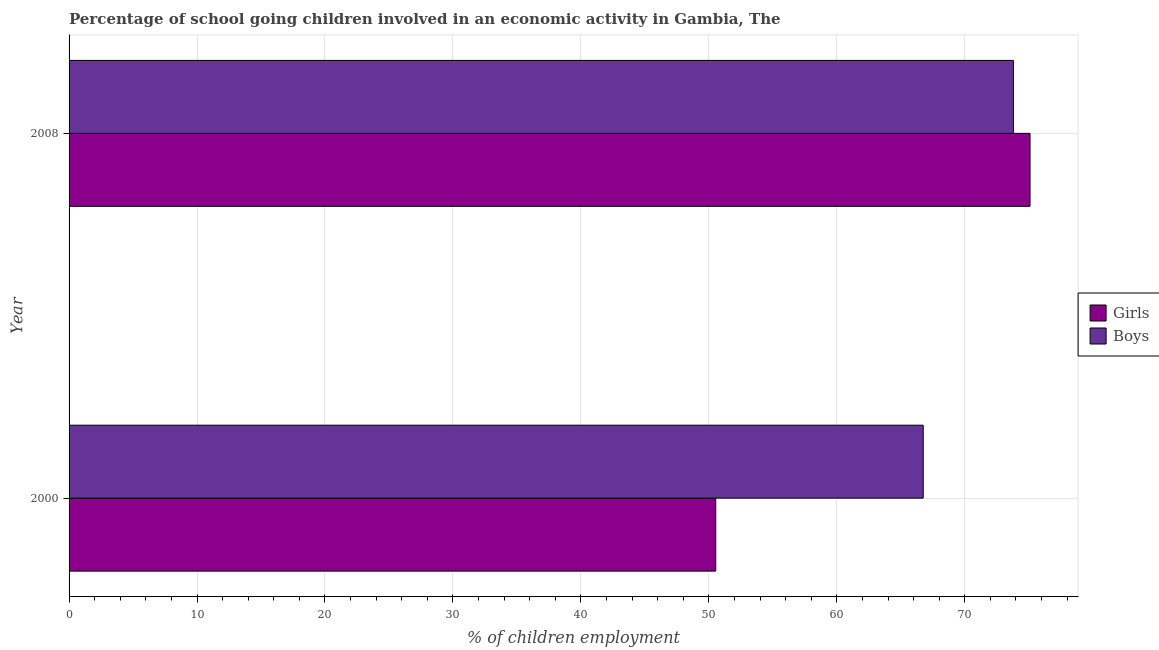How many different coloured bars are there?
Your answer should be very brief. 2. How many groups of bars are there?
Make the answer very short. 2. How many bars are there on the 2nd tick from the top?
Offer a terse response. 2. What is the label of the 2nd group of bars from the top?
Make the answer very short. 2000. What is the percentage of school going girls in 2000?
Your answer should be compact. 50.54. Across all years, what is the maximum percentage of school going girls?
Offer a very short reply. 75.1. Across all years, what is the minimum percentage of school going girls?
Your answer should be very brief. 50.54. In which year was the percentage of school going boys maximum?
Make the answer very short. 2008. In which year was the percentage of school going girls minimum?
Offer a terse response. 2000. What is the total percentage of school going boys in the graph?
Your answer should be very brief. 140.55. What is the difference between the percentage of school going girls in 2000 and that in 2008?
Make the answer very short. -24.56. What is the difference between the percentage of school going girls in 2000 and the percentage of school going boys in 2008?
Give a very brief answer. -23.26. What is the average percentage of school going boys per year?
Make the answer very short. 70.28. In how many years, is the percentage of school going boys greater than 72 %?
Make the answer very short. 1. What is the ratio of the percentage of school going boys in 2000 to that in 2008?
Your answer should be very brief. 0.9. Is the difference between the percentage of school going girls in 2000 and 2008 greater than the difference between the percentage of school going boys in 2000 and 2008?
Ensure brevity in your answer.  No. What does the 1st bar from the top in 2000 represents?
Keep it short and to the point. Boys. What does the 2nd bar from the bottom in 2000 represents?
Offer a very short reply. Boys. How many bars are there?
Your answer should be very brief. 4. Are all the bars in the graph horizontal?
Give a very brief answer. Yes. How many years are there in the graph?
Your response must be concise. 2. Does the graph contain grids?
Offer a very short reply. Yes. Where does the legend appear in the graph?
Offer a terse response. Center right. What is the title of the graph?
Your answer should be very brief. Percentage of school going children involved in an economic activity in Gambia, The. Does "From World Bank" appear as one of the legend labels in the graph?
Your answer should be compact. No. What is the label or title of the X-axis?
Your response must be concise. % of children employment. What is the label or title of the Y-axis?
Your answer should be very brief. Year. What is the % of children employment in Girls in 2000?
Offer a terse response. 50.54. What is the % of children employment of Boys in 2000?
Offer a very short reply. 66.75. What is the % of children employment in Girls in 2008?
Your response must be concise. 75.1. What is the % of children employment in Boys in 2008?
Give a very brief answer. 73.8. Across all years, what is the maximum % of children employment in Girls?
Offer a very short reply. 75.1. Across all years, what is the maximum % of children employment in Boys?
Your answer should be very brief. 73.8. Across all years, what is the minimum % of children employment in Girls?
Your response must be concise. 50.54. Across all years, what is the minimum % of children employment in Boys?
Offer a terse response. 66.75. What is the total % of children employment of Girls in the graph?
Give a very brief answer. 125.64. What is the total % of children employment of Boys in the graph?
Your answer should be very brief. 140.55. What is the difference between the % of children employment in Girls in 2000 and that in 2008?
Give a very brief answer. -24.56. What is the difference between the % of children employment of Boys in 2000 and that in 2008?
Give a very brief answer. -7.05. What is the difference between the % of children employment in Girls in 2000 and the % of children employment in Boys in 2008?
Provide a short and direct response. -23.26. What is the average % of children employment of Girls per year?
Provide a short and direct response. 62.82. What is the average % of children employment of Boys per year?
Keep it short and to the point. 70.28. In the year 2000, what is the difference between the % of children employment in Girls and % of children employment in Boys?
Provide a short and direct response. -16.21. In the year 2008, what is the difference between the % of children employment of Girls and % of children employment of Boys?
Offer a terse response. 1.3. What is the ratio of the % of children employment of Girls in 2000 to that in 2008?
Provide a short and direct response. 0.67. What is the ratio of the % of children employment in Boys in 2000 to that in 2008?
Offer a very short reply. 0.9. What is the difference between the highest and the second highest % of children employment in Girls?
Provide a succinct answer. 24.56. What is the difference between the highest and the second highest % of children employment of Boys?
Provide a short and direct response. 7.05. What is the difference between the highest and the lowest % of children employment in Girls?
Your answer should be very brief. 24.56. What is the difference between the highest and the lowest % of children employment of Boys?
Your response must be concise. 7.05. 